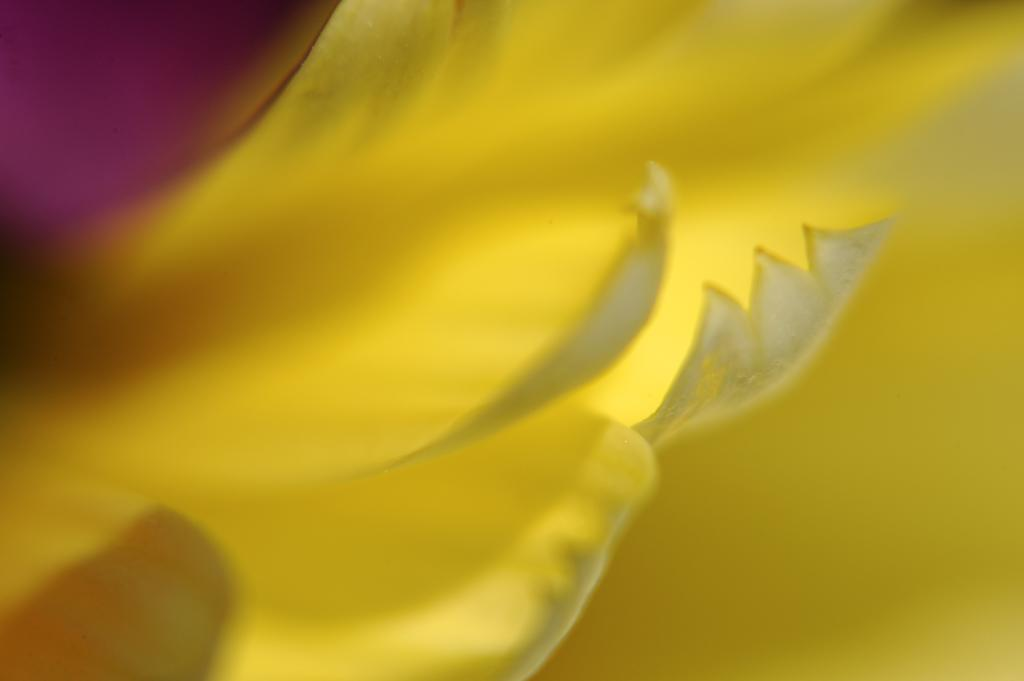What can be said about the image quality? The image quality is not clear. Despite the image quality, can you identify any objects in the image? Yes, there are objects visible in the image, but their specific details cannot be accurately determined. What type of lace can be seen on the clothing of the person in the image? There is no person visible in the image, and therefore no clothing or lace can be observed. Can you describe the curve of the road in the image? There is no road visible in the image, so it is not possible to describe the curve of a road. 